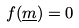<formula> <loc_0><loc_0><loc_500><loc_500>f ( \underline { m } ) = 0</formula> 